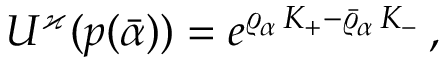<formula> <loc_0><loc_0><loc_500><loc_500>U ^ { \varkappa } ( p ( \bar { \alpha } ) ) = e ^ { \varrho _ { \alpha } \, K _ { + } - \bar { \varrho } _ { \alpha } \, K _ { - } } \, ,</formula> 